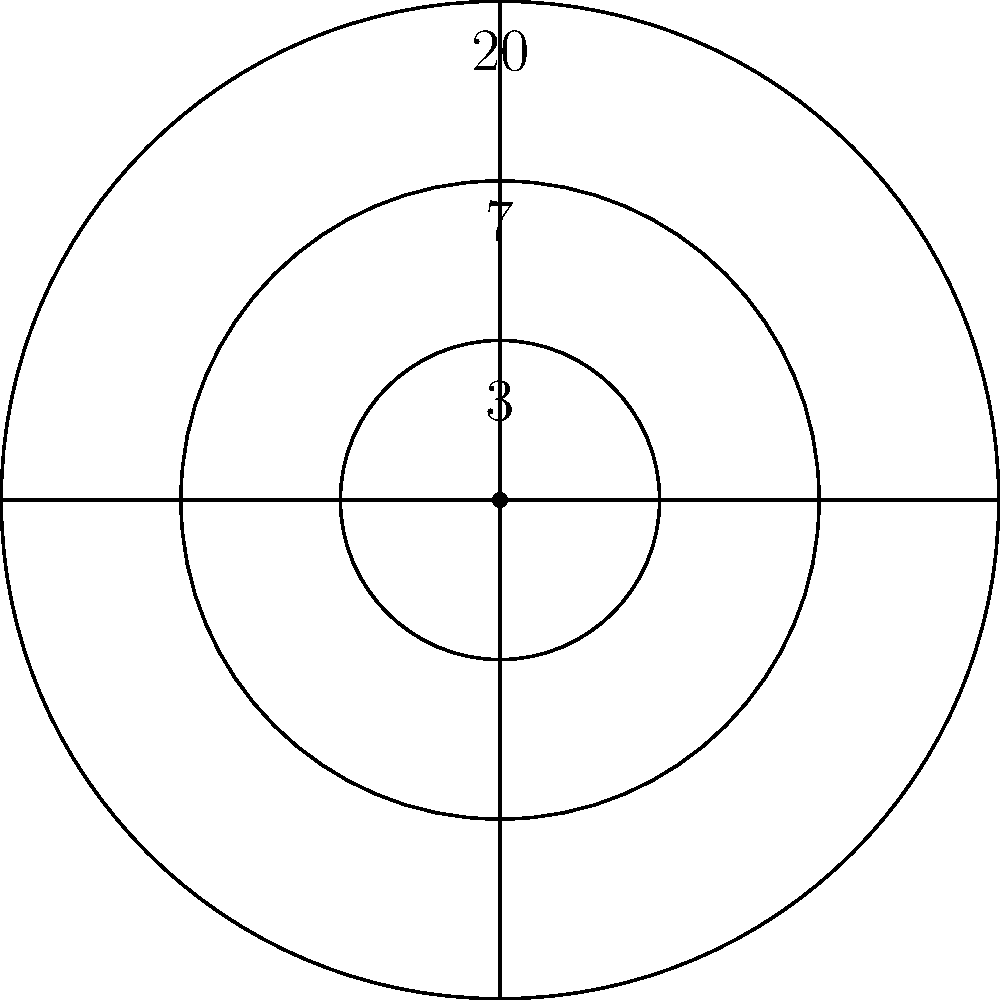In your fantasy dart league, players score points based on their accuracy. The dartboard has three circular regions: the bullseye (inner circle), the middle ring, and the outer ring. The radii of these regions are in the ratio 1:2:3, and the total radius of the board is 10 inches. If a dart lands randomly on the board, what is the probability that it will land in the middle ring? Express your answer as a percentage rounded to two decimal places. Let's approach this step-by-step:

1) First, we need to calculate the radii of each region:
   Let $x$ be the radius of the bullseye.
   Then, $2x$ is the radius of the middle ring, and $3x$ is the radius of the outer ring.
   We know that $3x = 10$ inches (total radius).
   So, $x = \frac{10}{3}$ inches.

2) Now we have:
   Bullseye radius: $\frac{10}{3}$ inches
   Middle ring outer radius: $2 \cdot \frac{10}{3} = \frac{20}{3}$ inches
   Outer ring radius (total radius): 10 inches

3) The probability of landing in a region is proportional to its area. We need to calculate the areas:

   Area of bullseye: $A_1 = \pi (\frac{10}{3})^2 = \frac{100\pi}{9}$ sq inches
   
   Area of middle ring: $A_2 = \pi (\frac{20}{3})^2 - \pi (\frac{10}{3})^2 = \frac{300\pi}{9}$ sq inches
   
   Total area of board: $A_t = \pi (10)^2 = 100\pi$ sq inches

4) The probability of landing in the middle ring is:

   $P(\text{middle ring}) = \frac{A_2}{A_t} = \frac{\frac{300\pi}{9}}{100\pi} = \frac{300}{900} = \frac{1}{3}$

5) Converting to a percentage:
   $\frac{1}{3} \approx 0.3333 \approx 33.33\%$
Answer: 33.33% 